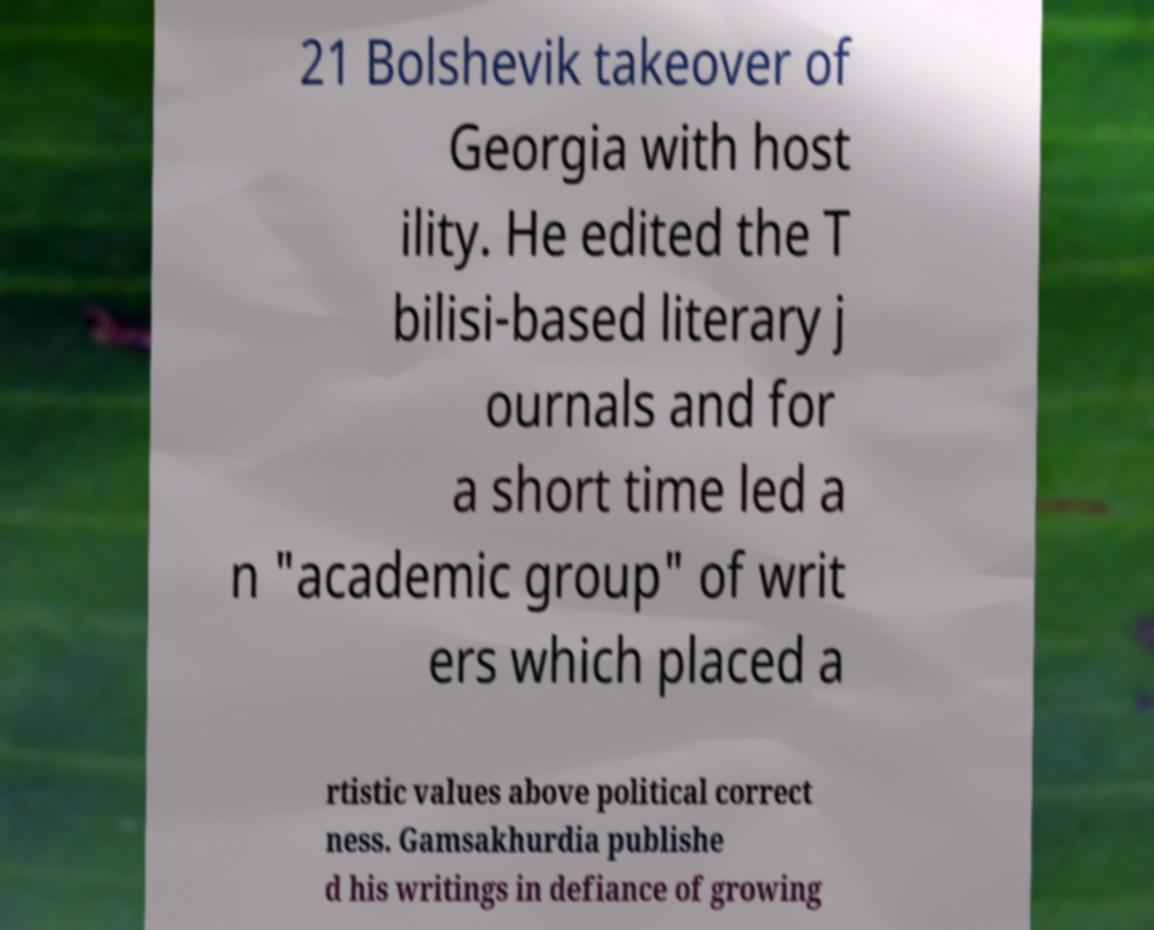Can you accurately transcribe the text from the provided image for me? 21 Bolshevik takeover of Georgia with host ility. He edited the T bilisi-based literary j ournals and for a short time led a n "academic group" of writ ers which placed a rtistic values above political correct ness. Gamsakhurdia publishe d his writings in defiance of growing 